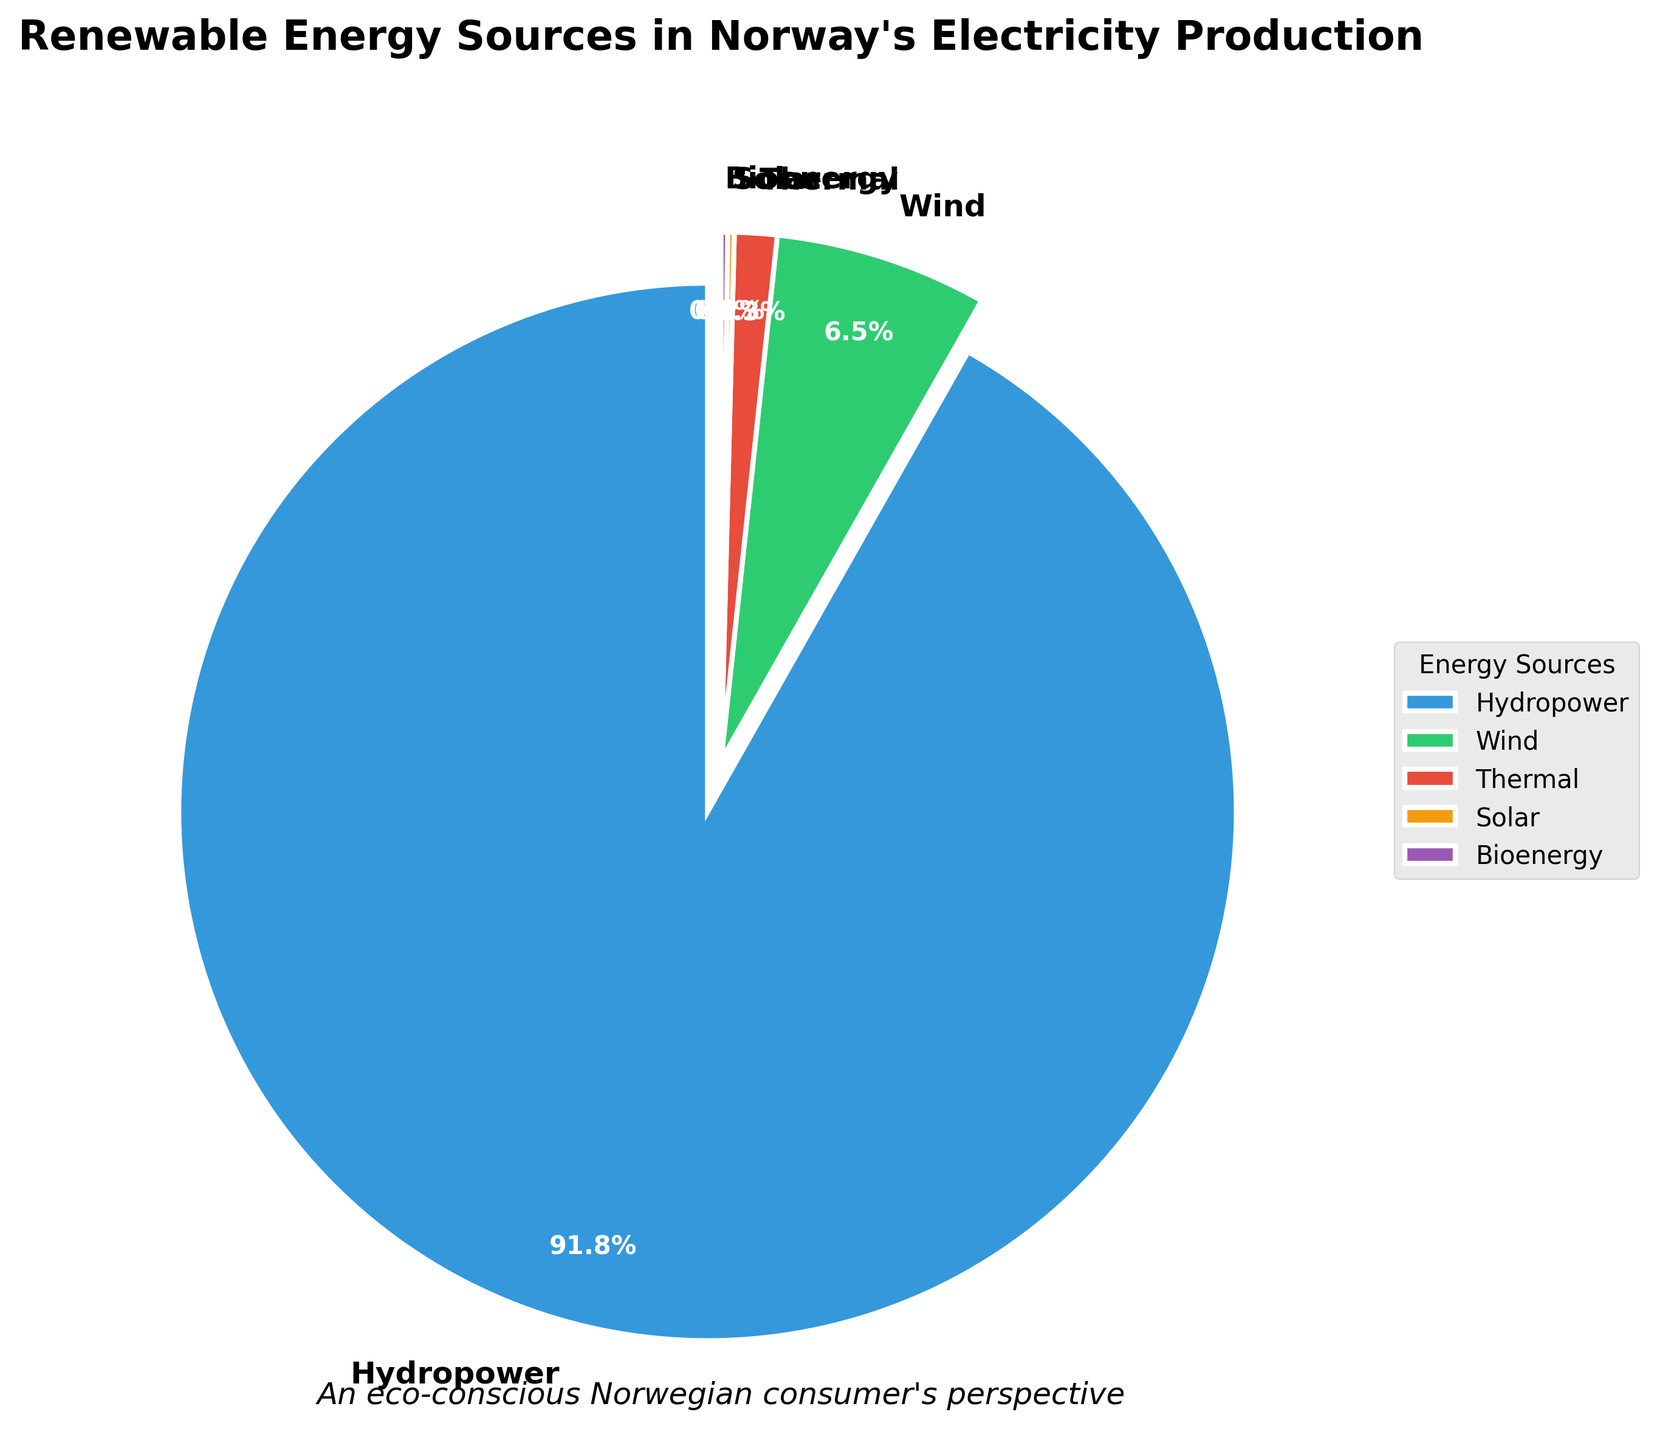What's the largest source of renewable energy in Norway's electricity production? The figure shows a pie chart with various energy sources listed and their percentages. The largest wedge corresponds to Hydropower at 91.8%.
Answer: Hydropower Which two energy sources contribute equally to Norway's electricity production? By observing the pie chart, both Solar and Bioenergy have equal percentages of 0.2%.
Answer: Solar and Bioenergy What percentage of Norway's electricity production is generated by solar and bioenergy combined? From the pie chart, Solar and Bioenergy both contribute 0.2%. Adding these together gives 0.2% + 0.2% = 0.4%.
Answer: 0.4% How much more electricity does wind energy produce compared to thermal energy? According to the chart, Wind produces 6.5% and Thermal produces 1.3%. The difference is 6.5% - 1.3% = 5.2%.
Answer: 5.2% Which energy source has the smallest contribution, and what is its percentage? The smallest contribution can be determined by looking at the smallest wedge in the pie chart, which corresponds to Solar (0.2%) and Bioenergy (0.2%).
Answer: Solar and Bioenergy, 0.2% How many times more electricity does hydropower produce compared to wind energy? Hydropower contributes 91.8%, while Wind contributes 6.5%. The ratio is 91.8% / 6.5% ≈ 14.12.
Answer: Approximately 14 times If 100 units of electricity are produced, how many units come from thermal energy? Thermal energy contributes 1.3% of the total electricity. Therefore, 1.3% of 100 units is 1.3 units.
Answer: 1.3 units What visual attributes help identify hydropower as the leading energy source? Hydropower is represented by the largest wedge in the pie chart, and it’s also positioned closest to the beginning of the chart, often highlighted by a slight explosion of the wedge.
Answer: Largest wedge, exploded wedge Which colored wedge represents wind energy, and what is its percentage? The pie chart uses different colors for each energy source. Wind energy is represented by a green wedge and accounts for 6.5% of the total.
Answer: Green, 6.5% In what way does the figure highlight the importance of hydropower visually? The pie chart uses a larger-sized wedge and an explosion effect for Hydropower to draw attention to its dominance in electricity production. The wedge also has a bold border and white edge color.
Answer: Large wedge, exploded effect, bold border, white edges 